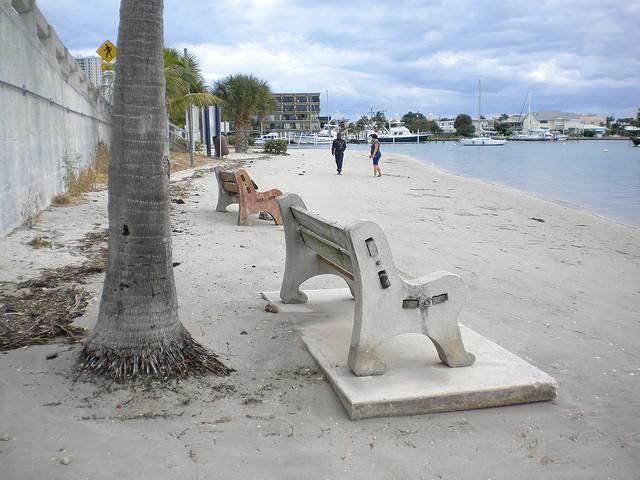How many benches are there?
Give a very brief answer. 2. 